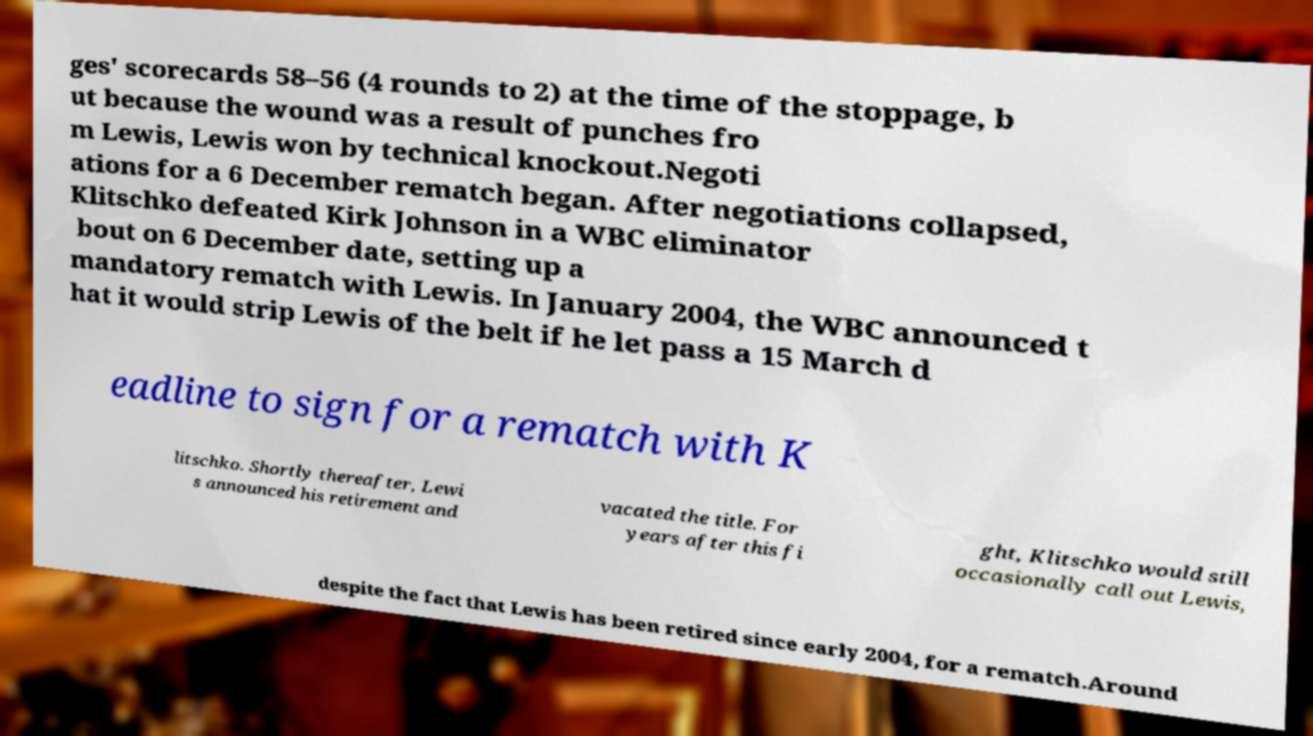I need the written content from this picture converted into text. Can you do that? ges' scorecards 58–56 (4 rounds to 2) at the time of the stoppage, b ut because the wound was a result of punches fro m Lewis, Lewis won by technical knockout.Negoti ations for a 6 December rematch began. After negotiations collapsed, Klitschko defeated Kirk Johnson in a WBC eliminator bout on 6 December date, setting up a mandatory rematch with Lewis. In January 2004, the WBC announced t hat it would strip Lewis of the belt if he let pass a 15 March d eadline to sign for a rematch with K litschko. Shortly thereafter, Lewi s announced his retirement and vacated the title. For years after this fi ght, Klitschko would still occasionally call out Lewis, despite the fact that Lewis has been retired since early 2004, for a rematch.Around 